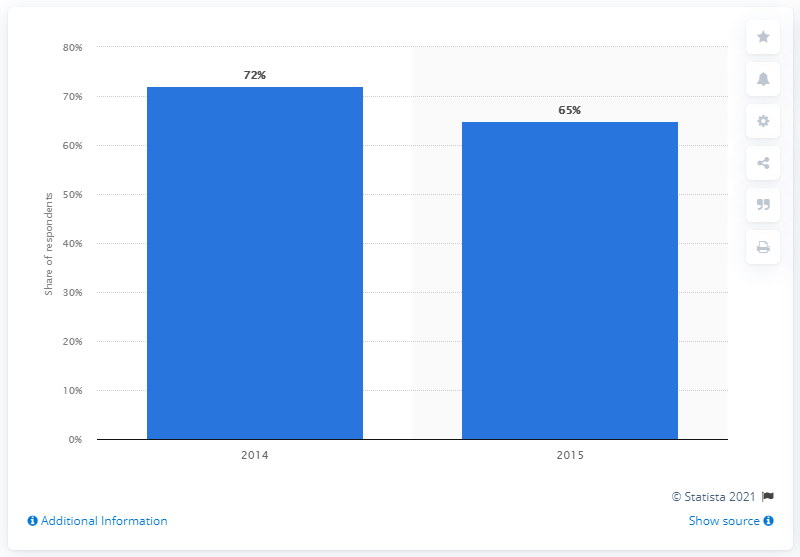Specify some key components in this picture. In the year 2015, 65% of homeowners were asked about their plans for home improvement projects. 